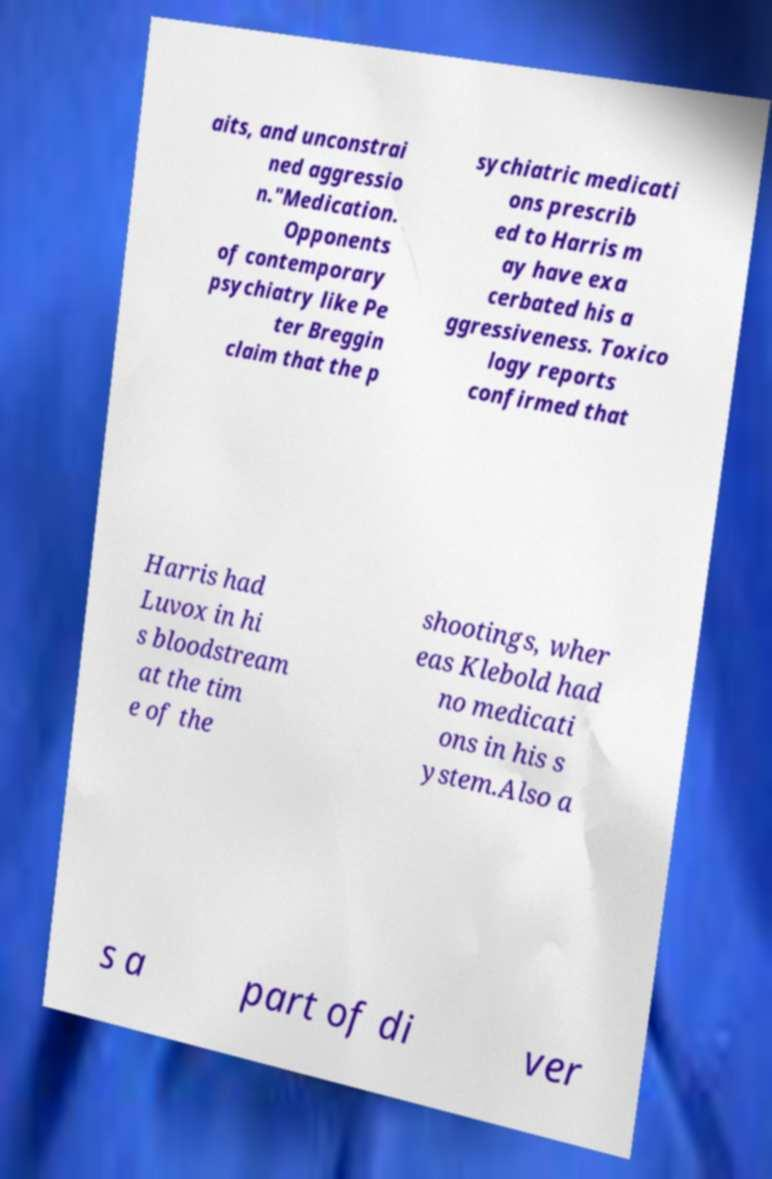Could you extract and type out the text from this image? aits, and unconstrai ned aggressio n."Medication. Opponents of contemporary psychiatry like Pe ter Breggin claim that the p sychiatric medicati ons prescrib ed to Harris m ay have exa cerbated his a ggressiveness. Toxico logy reports confirmed that Harris had Luvox in hi s bloodstream at the tim e of the shootings, wher eas Klebold had no medicati ons in his s ystem.Also a s a part of di ver 